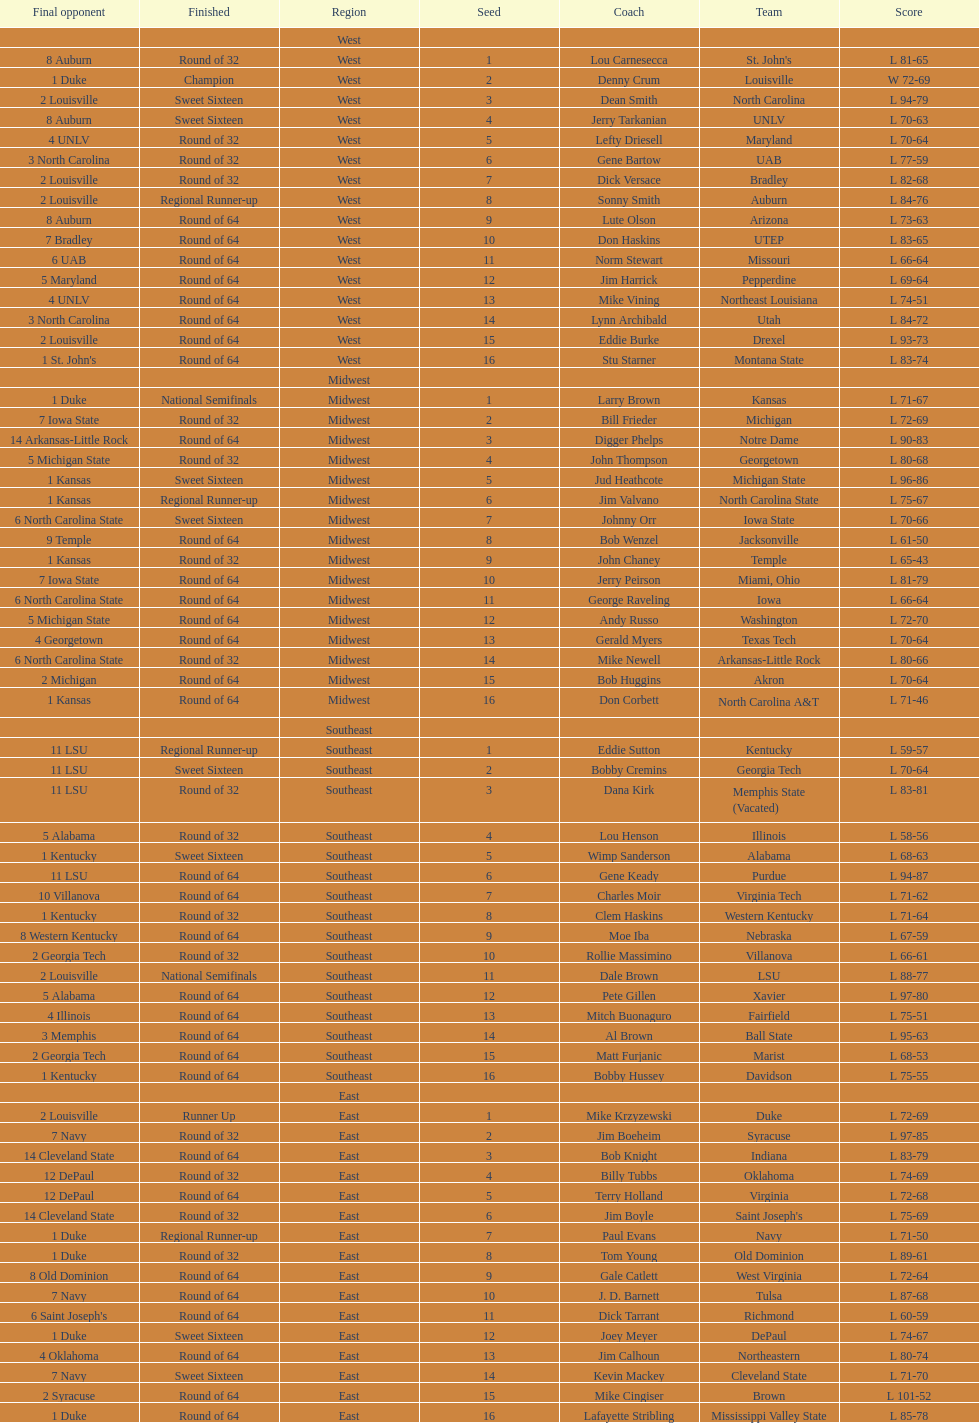How many teams are in the east region. 16. 